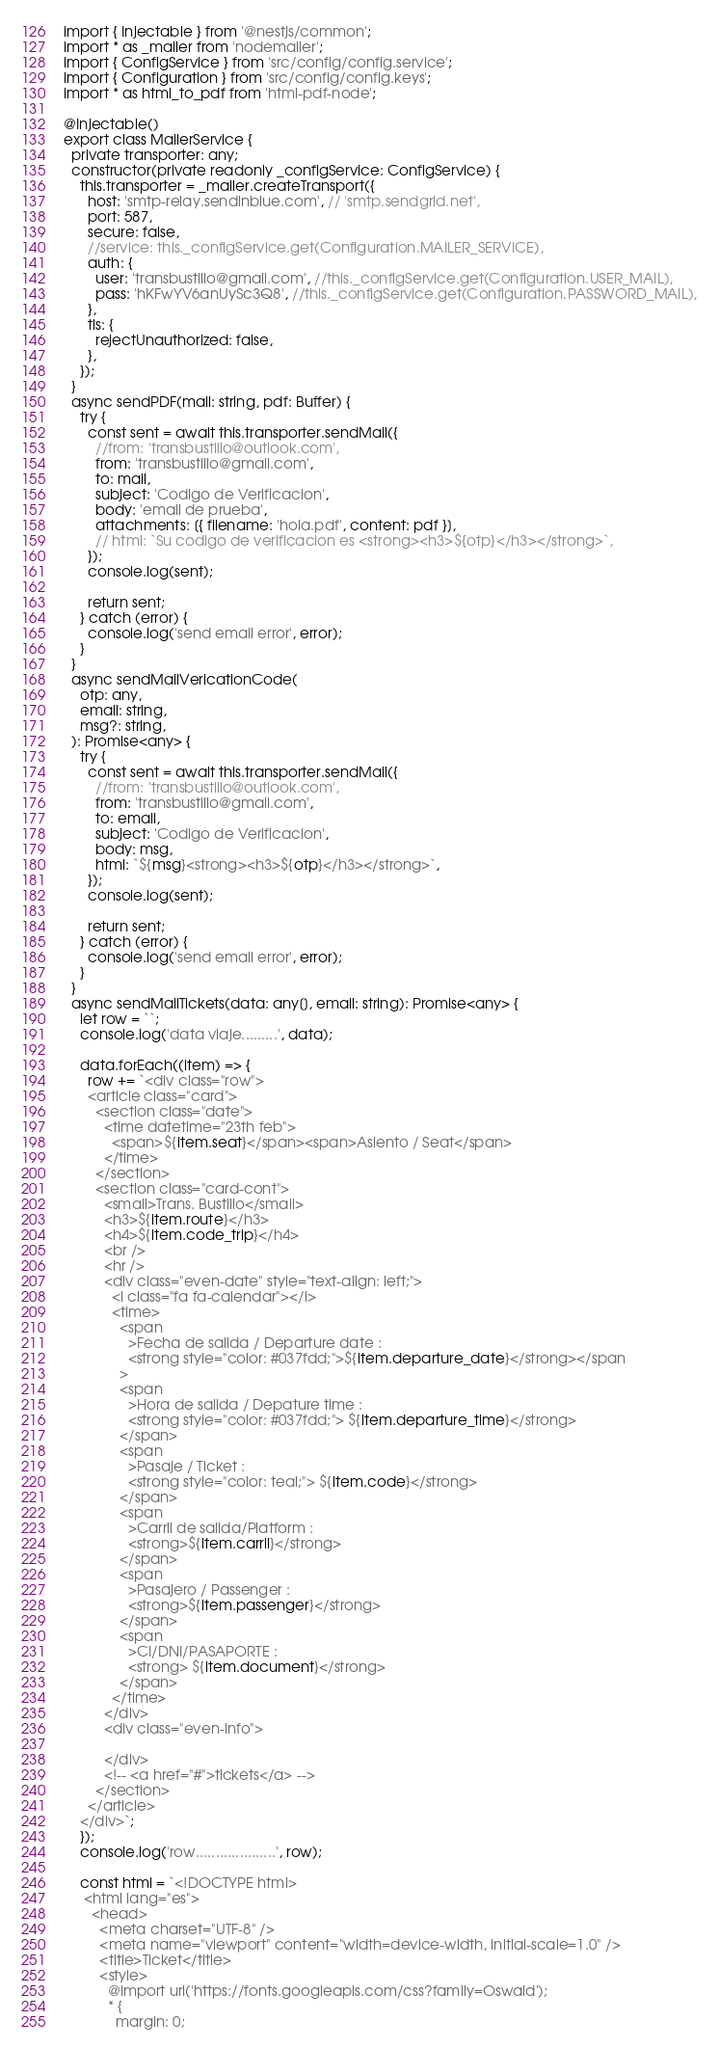<code> <loc_0><loc_0><loc_500><loc_500><_TypeScript_>import { Injectable } from '@nestjs/common';
import * as _mailer from 'nodemailer';
import { ConfigService } from 'src/config/config.service';
import { Configuration } from 'src/config/config.keys';
import * as html_to_pdf from 'html-pdf-node';

@Injectable()
export class MailerService {
  private transporter: any;
  constructor(private readonly _configService: ConfigService) {
    this.transporter = _mailer.createTransport({
      host: 'smtp-relay.sendinblue.com', // 'smtp.sendgrid.net',
      port: 587,
      secure: false,
      //service: this._configService.get(Configuration.MAILER_SERVICE),
      auth: {
        user: 'transbustillo@gmail.com', //this._configService.get(Configuration.USER_MAIL),
        pass: 'hKFwYV6anUySc3Q8', //this._configService.get(Configuration.PASSWORD_MAIL),
      },
      tls: {
        rejectUnauthorized: false,
      },
    });
  }
  async sendPDF(mail: string, pdf: Buffer) {
    try {
      const sent = await this.transporter.sendMail({
        //from: 'transbustillo@outlook.com',
        from: 'transbustillo@gmail.com',
        to: mail,
        subject: 'Codigo de Verificacion',
        body: 'email de prueba',
        attachments: [{ filename: 'hola.pdf', content: pdf }],
        // html: `Su codigo de verificacion es <strong><h3>${otp}</h3></strong>`,
      });
      console.log(sent);

      return sent;
    } catch (error) {
      console.log('send email error', error);
    }
  }
  async sendMailVericationCode(
    otp: any,
    email: string,
    msg?: string,
  ): Promise<any> {
    try {
      const sent = await this.transporter.sendMail({
        //from: 'transbustillo@outlook.com',
        from: 'transbustillo@gmail.com',
        to: email,
        subject: 'Codigo de Verificacion',
        body: msg,
        html: `${msg}<strong><h3>${otp}</h3></strong>`,
      });
      console.log(sent);

      return sent;
    } catch (error) {
      console.log('send email error', error);
    }
  }
  async sendMailTickets(data: any[], email: string): Promise<any> {
    let row = ``;
    console.log('data viaje.........', data);

    data.forEach((item) => {
      row += `<div class="row">
      <article class="card">
        <section class="date">
          <time datetime="23th feb">
            <span>${item.seat}</span><span>Asiento / Seat</span>
          </time>
        </section>
        <section class="card-cont">
          <small>Trans. Bustillo</small>
          <h3>${item.route}</h3>
          <h4>${item.code_trip}</h4>
          <br />
          <hr />
          <div class="even-date" style="text-align: left;">
            <i class="fa fa-calendar"></i>
            <time>
              <span
                >Fecha de salida / Departure date :
                <strong style="color: #037fdd;">${item.departure_date}</strong></span
              >
              <span
                >Hora de salida / Depature time :
                <strong style="color: #037fdd;"> ${item.departure_time}</strong>
              </span>
              <span
                >Pasaje / Ticket :
                <strong style="color: teal;"> ${item.code}</strong>
              </span>
              <span
                >Carril de salida/Platform :
                <strong>${item.carril}</strong>
              </span>
              <span
                >Pasajero / Passenger :
                <strong>${item.passenger}</strong>
              </span>
              <span
                >CI/DNI/PASAPORTE :
                <strong> ${item.document}</strong>
              </span>
            </time>
          </div>
          <div class="even-info">
            
          </div>
          <!-- <a href="#">tickets</a> -->
        </section>
      </article>
    </div>`;
    });
    console.log('row....................', row);

    const html = `<!DOCTYPE html>
     <html lang="es">
       <head>
         <meta charset="UTF-8" />
         <meta name="viewport" content="width=device-width, initial-scale=1.0" />
         <title>Ticket</title>
         <style>
           @import url('https://fonts.googleapis.com/css?family=Oswald');
           * {
             margin: 0;</code> 